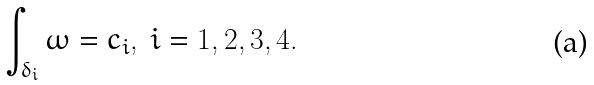<formula> <loc_0><loc_0><loc_500><loc_500>\int _ { \delta _ { i } } \omega = c _ { i } , \ i = 1 , 2 , 3 , 4 .</formula> 